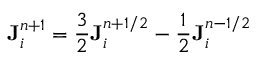<formula> <loc_0><loc_0><loc_500><loc_500>{ J } _ { i } ^ { n + 1 } = \frac { 3 } { 2 } { J } _ { i } ^ { n + 1 / 2 } - \frac { 1 } { 2 } { J } _ { i } ^ { n - 1 / 2 }</formula> 